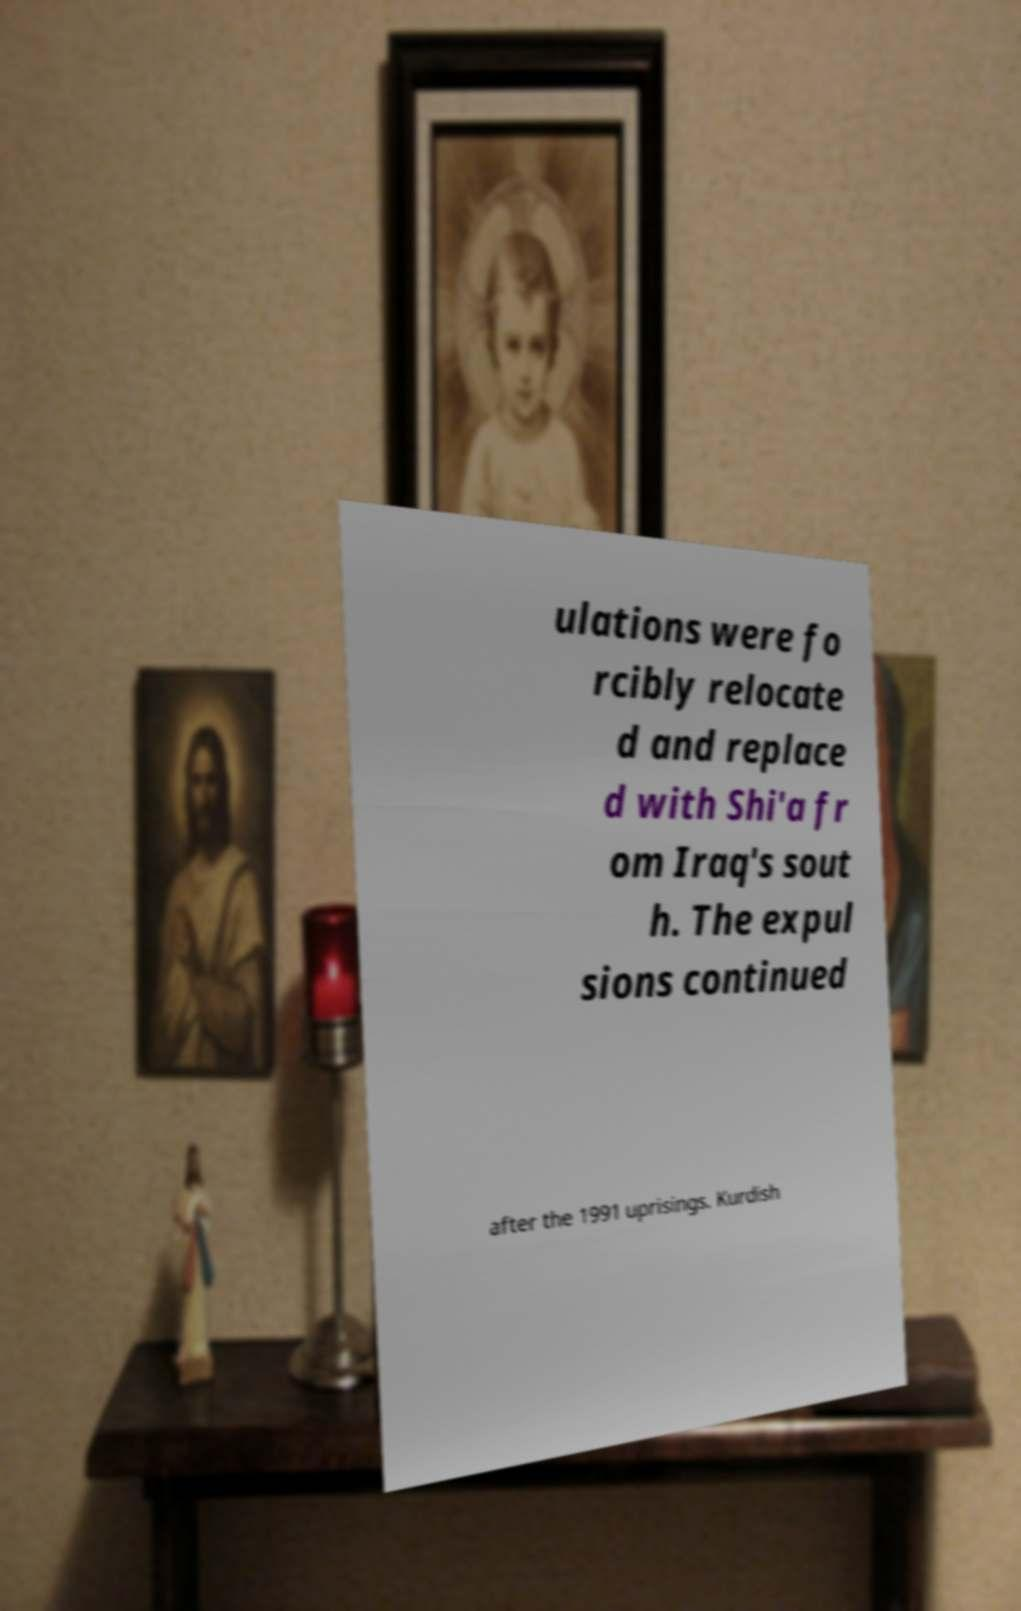Could you extract and type out the text from this image? ulations were fo rcibly relocate d and replace d with Shi'a fr om Iraq's sout h. The expul sions continued after the 1991 uprisings. Kurdish 